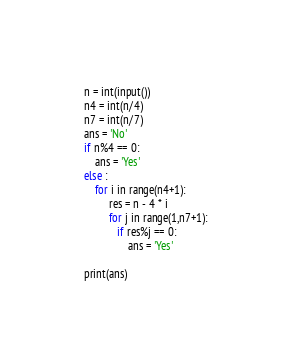Convert code to text. <code><loc_0><loc_0><loc_500><loc_500><_Python_>n = int(input())
n4 = int(n/4)
n7 = int(n/7)
ans = 'No'
if n%4 == 0:
    ans = 'Yes'
else :
    for i in range(n4+1):
         res = n - 4 * i
         for j in range(1,n7+1):
            if res%j == 0:
                ans = 'Yes'

print(ans)




</code> 